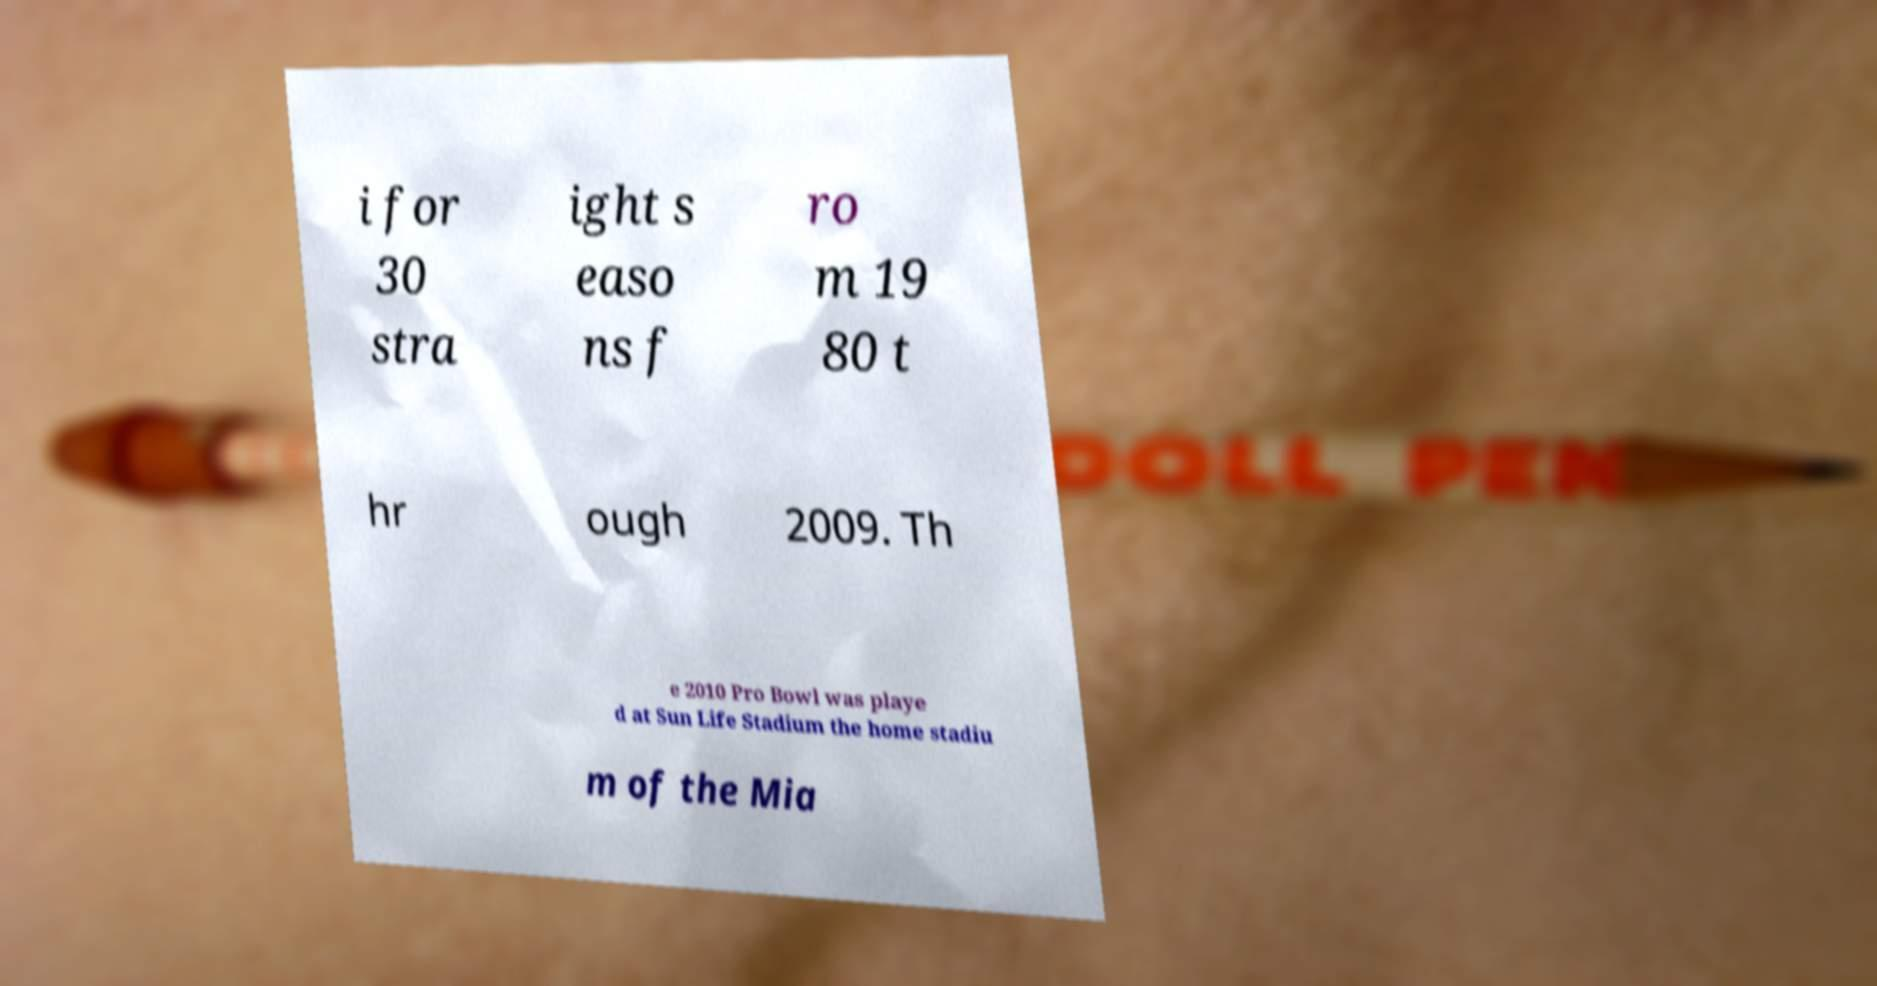Please identify and transcribe the text found in this image. i for 30 stra ight s easo ns f ro m 19 80 t hr ough 2009. Th e 2010 Pro Bowl was playe d at Sun Life Stadium the home stadiu m of the Mia 